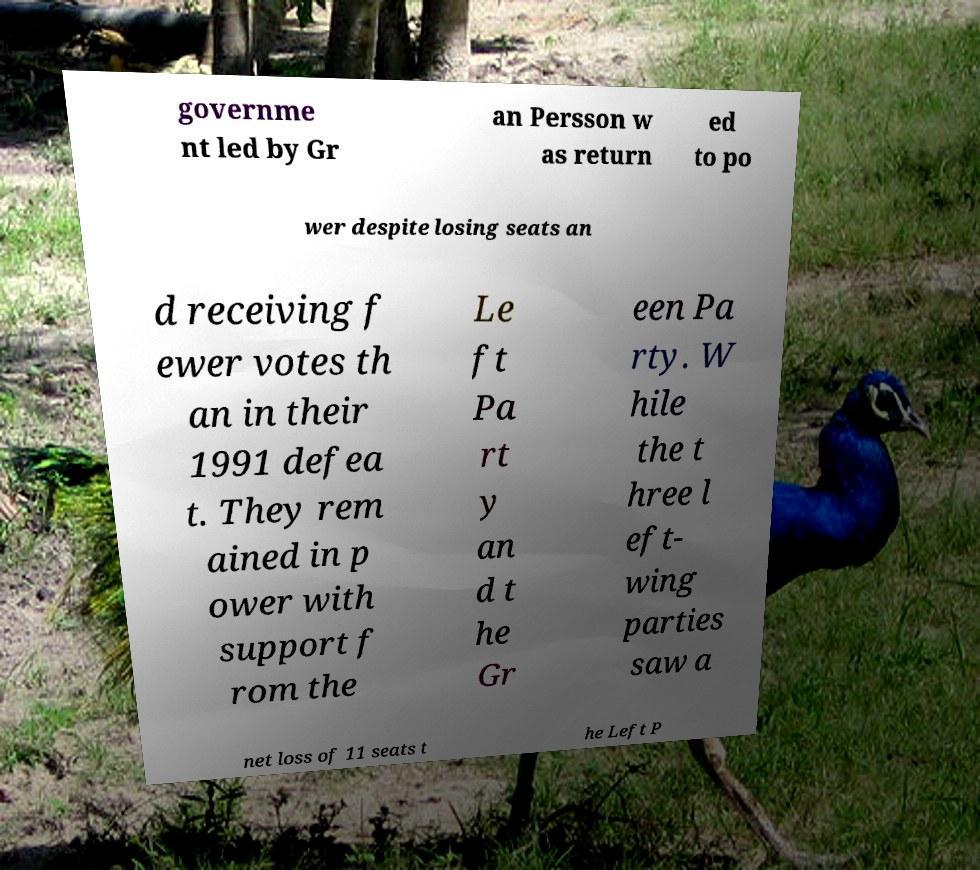For documentation purposes, I need the text within this image transcribed. Could you provide that? governme nt led by Gr an Persson w as return ed to po wer despite losing seats an d receiving f ewer votes th an in their 1991 defea t. They rem ained in p ower with support f rom the Le ft Pa rt y an d t he Gr een Pa rty. W hile the t hree l eft- wing parties saw a net loss of 11 seats t he Left P 